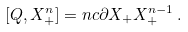<formula> <loc_0><loc_0><loc_500><loc_500>[ Q , X ^ { n } _ { + } ] = n c \partial X _ { + } X _ { + } ^ { n - 1 } \, .</formula> 